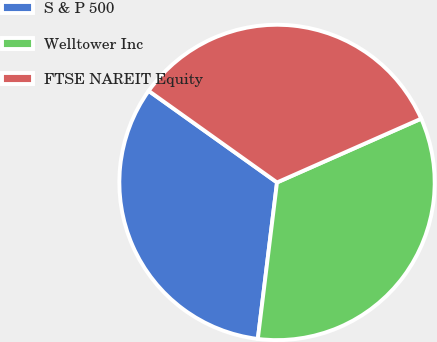Convert chart. <chart><loc_0><loc_0><loc_500><loc_500><pie_chart><fcel>S & P 500<fcel>Welltower Inc<fcel>FTSE NAREIT Equity<nl><fcel>32.92%<fcel>33.57%<fcel>33.51%<nl></chart> 